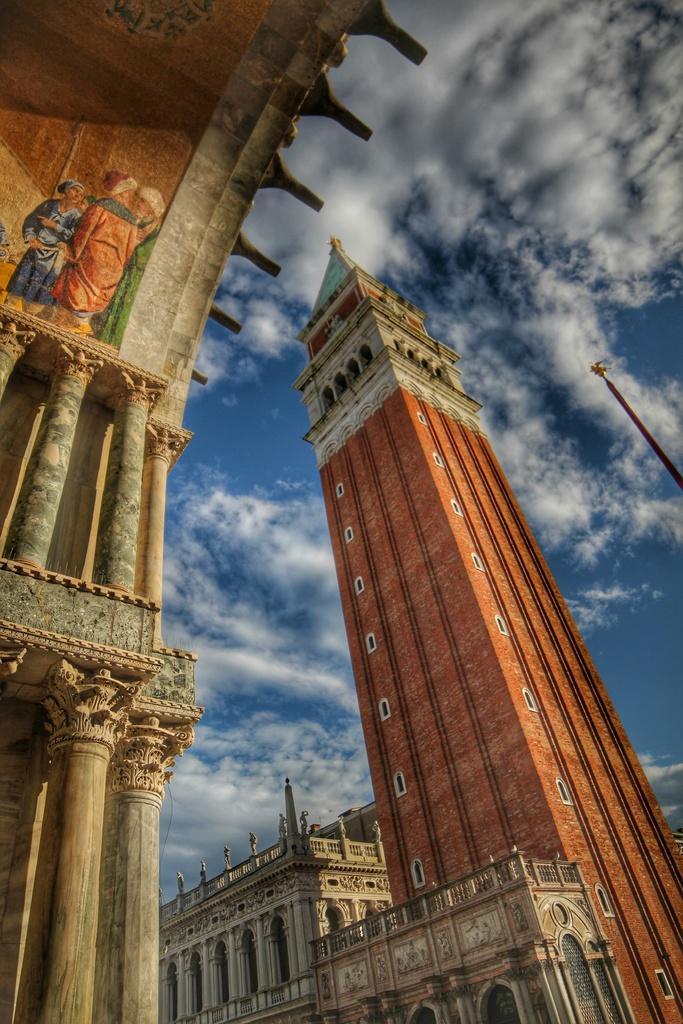In one or two sentences, can you explain what this image depicts? In this image there are buildings, in the background there is the sky. 